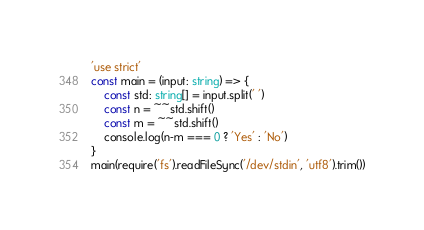<code> <loc_0><loc_0><loc_500><loc_500><_TypeScript_>'use strict'
const main = (input: string) => {
    const std: string[] = input.split(' ')
    const n = ~~std.shift()
    const m = ~~std.shift()
    console.log(n-m === 0 ? 'Yes' : 'No')
}
main(require('fs').readFileSync('/dev/stdin', 'utf8').trim())
</code> 